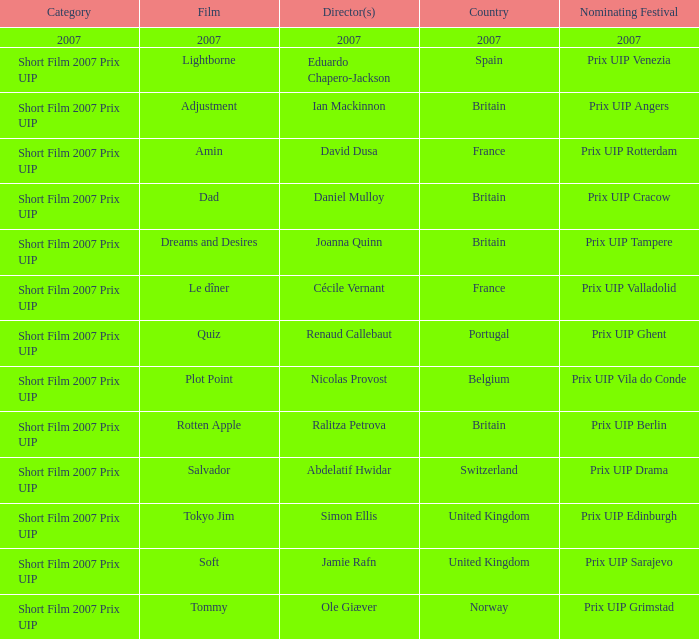Give me the full table as a dictionary. {'header': ['Category', 'Film', 'Director(s)', 'Country', 'Nominating Festival'], 'rows': [['2007', '2007', '2007', '2007', '2007'], ['Short Film 2007 Prix UIP', 'Lightborne', 'Eduardo Chapero-Jackson', 'Spain', 'Prix UIP Venezia'], ['Short Film 2007 Prix UIP', 'Adjustment', 'Ian Mackinnon', 'Britain', 'Prix UIP Angers'], ['Short Film 2007 Prix UIP', 'Amin', 'David Dusa', 'France', 'Prix UIP Rotterdam'], ['Short Film 2007 Prix UIP', 'Dad', 'Daniel Mulloy', 'Britain', 'Prix UIP Cracow'], ['Short Film 2007 Prix UIP', 'Dreams and Desires', 'Joanna Quinn', 'Britain', 'Prix UIP Tampere'], ['Short Film 2007 Prix UIP', 'Le dîner', 'Cécile Vernant', 'France', 'Prix UIP Valladolid'], ['Short Film 2007 Prix UIP', 'Quiz', 'Renaud Callebaut', 'Portugal', 'Prix UIP Ghent'], ['Short Film 2007 Prix UIP', 'Plot Point', 'Nicolas Provost', 'Belgium', 'Prix UIP Vila do Conde'], ['Short Film 2007 Prix UIP', 'Rotten Apple', 'Ralitza Petrova', 'Britain', 'Prix UIP Berlin'], ['Short Film 2007 Prix UIP', 'Salvador', 'Abdelatif Hwidar', 'Switzerland', 'Prix UIP Drama'], ['Short Film 2007 Prix UIP', 'Tokyo Jim', 'Simon Ellis', 'United Kingdom', 'Prix UIP Edinburgh'], ['Short Film 2007 Prix UIP', 'Soft', 'Jamie Rafn', 'United Kingdom', 'Prix UIP Sarajevo'], ['Short Film 2007 Prix UIP', 'Tommy', 'Ole Giæver', 'Norway', 'Prix UIP Grimstad']]} Which movie was shot in spain? Lightborne. 